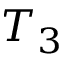<formula> <loc_0><loc_0><loc_500><loc_500>T _ { 3 }</formula> 